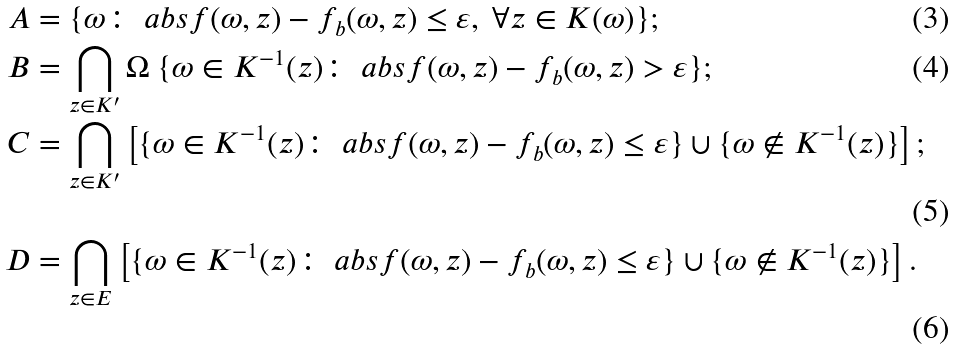Convert formula to latex. <formula><loc_0><loc_0><loc_500><loc_500>A & = \{ \omega \colon \ a b s { f ( \omega , z ) - f _ { b } ( \omega , z ) } \leq \varepsilon , \text { } \forall z \in K ( \omega ) \} ; \\ B & = \bigcap _ { z \in K ^ { \prime } } \Omega \ \{ \omega \in K ^ { - 1 } ( z ) \colon \ a b s { f ( \omega , z ) - f _ { b } ( \omega , z ) } > \varepsilon \} ; \\ C & = \bigcap _ { z \in K ^ { \prime } } \left [ \{ \omega \in K ^ { - 1 } ( z ) \colon \ a b s { f ( \omega , z ) - f _ { b } ( \omega , z ) } \leq \varepsilon \} \cup \{ \omega \not \in K ^ { - 1 } ( z ) \} \right ] ; \\ D & = \bigcap _ { z \in E } \left [ \{ \omega \in K ^ { - 1 } ( z ) \colon \ a b s { f ( \omega , z ) - f _ { b } ( \omega , z ) } \leq \varepsilon \} \cup \{ \omega \not \in K ^ { - 1 } ( z ) \} \right ] .</formula> 